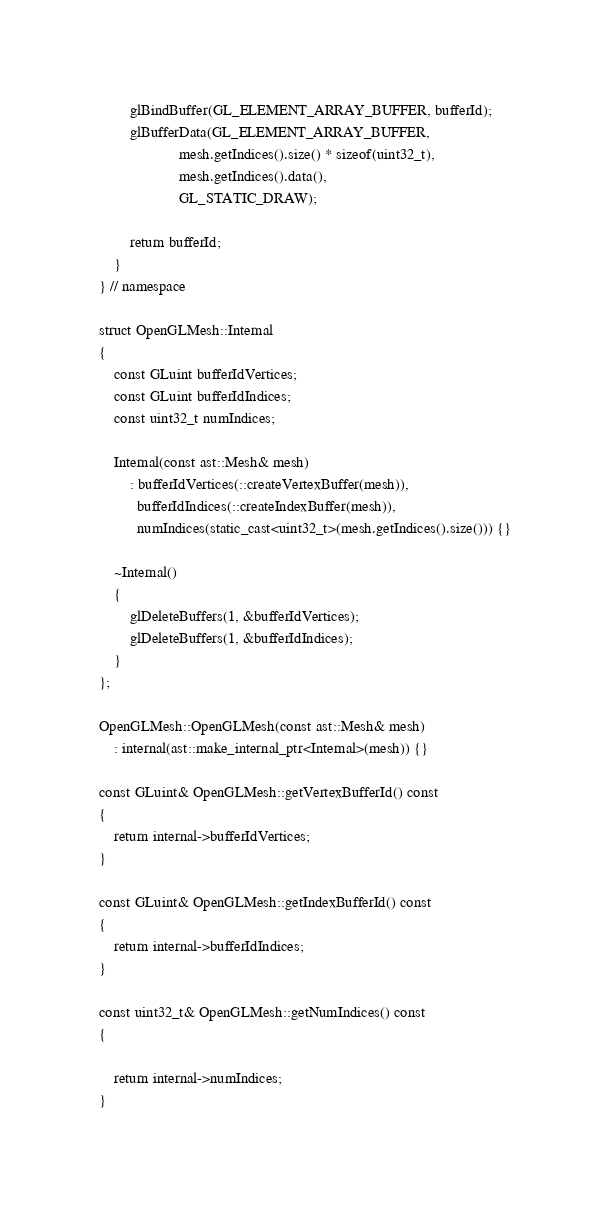<code> <loc_0><loc_0><loc_500><loc_500><_C++_>        glBindBuffer(GL_ELEMENT_ARRAY_BUFFER, bufferId);
        glBufferData(GL_ELEMENT_ARRAY_BUFFER,
                     mesh.getIndices().size() * sizeof(uint32_t),
                     mesh.getIndices().data(),
                     GL_STATIC_DRAW);

        return bufferId;
    }
} // namespace

struct OpenGLMesh::Internal
{
    const GLuint bufferIdVertices;
    const GLuint bufferIdIndices;
    const uint32_t numIndices;

    Internal(const ast::Mesh& mesh)
        : bufferIdVertices(::createVertexBuffer(mesh)),
          bufferIdIndices(::createIndexBuffer(mesh)),
          numIndices(static_cast<uint32_t>(mesh.getIndices().size())) {}

    ~Internal()
    {
        glDeleteBuffers(1, &bufferIdVertices);
        glDeleteBuffers(1, &bufferIdIndices);
    }
};

OpenGLMesh::OpenGLMesh(const ast::Mesh& mesh)
    : internal(ast::make_internal_ptr<Internal>(mesh)) {}

const GLuint& OpenGLMesh::getVertexBufferId() const
{
    return internal->bufferIdVertices;
}

const GLuint& OpenGLMesh::getIndexBufferId() const
{
    return internal->bufferIdIndices;
}

const uint32_t& OpenGLMesh::getNumIndices() const
{

    return internal->numIndices;
}</code> 